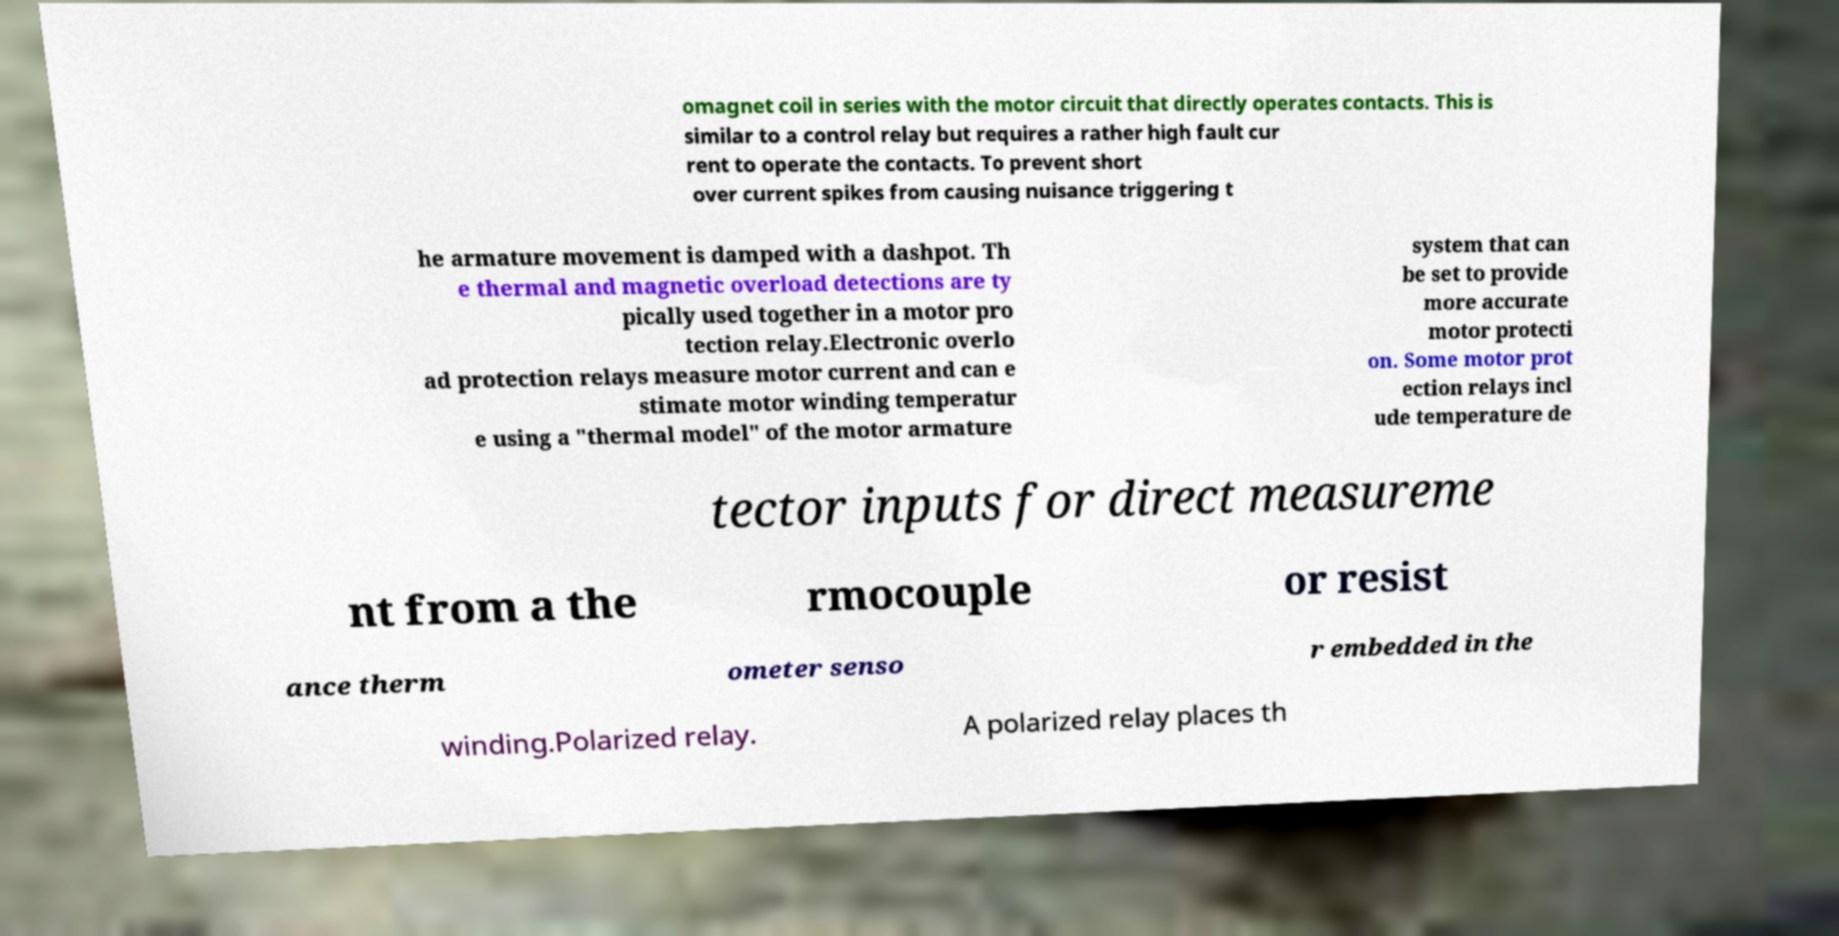Could you extract and type out the text from this image? omagnet coil in series with the motor circuit that directly operates contacts. This is similar to a control relay but requires a rather high fault cur rent to operate the contacts. To prevent short over current spikes from causing nuisance triggering t he armature movement is damped with a dashpot. Th e thermal and magnetic overload detections are ty pically used together in a motor pro tection relay.Electronic overlo ad protection relays measure motor current and can e stimate motor winding temperatur e using a "thermal model" of the motor armature system that can be set to provide more accurate motor protecti on. Some motor prot ection relays incl ude temperature de tector inputs for direct measureme nt from a the rmocouple or resist ance therm ometer senso r embedded in the winding.Polarized relay. A polarized relay places th 